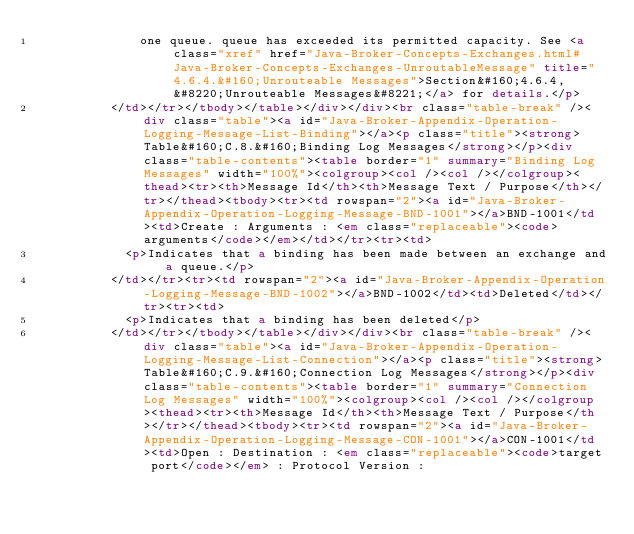<code> <loc_0><loc_0><loc_500><loc_500><_HTML_>              one queue. queue has exceeded its permitted capacity. See <a class="xref" href="Java-Broker-Concepts-Exchanges.html#Java-Broker-Concepts-Exchanges-UnroutableMessage" title="4.6.4.&#160;Unrouteable Messages">Section&#160;4.6.4, &#8220;Unrouteable Messages&#8221;</a> for details.</p>
          </td></tr></tbody></table></div></div><br class="table-break" /><div class="table"><a id="Java-Broker-Appendix-Operation-Logging-Message-List-Binding"></a><p class="title"><strong>Table&#160;C.8.&#160;Binding Log Messages</strong></p><div class="table-contents"><table border="1" summary="Binding Log Messages" width="100%"><colgroup><col /><col /></colgroup><thead><tr><th>Message Id</th><th>Message Text / Purpose</th></tr></thead><tbody><tr><td rowspan="2"><a id="Java-Broker-Appendix-Operation-Logging-Message-BND-1001"></a>BND-1001</td><td>Create : Arguments : <em class="replaceable"><code>arguments</code></em></td></tr><tr><td>
            <p>Indicates that a binding has been made between an exchange and a queue.</p>
          </td></tr><tr><td rowspan="2"><a id="Java-Broker-Appendix-Operation-Logging-Message-BND-1002"></a>BND-1002</td><td>Deleted</td></tr><tr><td>
            <p>Indicates that a binding has been deleted</p>
          </td></tr></tbody></table></div></div><br class="table-break" /><div class="table"><a id="Java-Broker-Appendix-Operation-Logging-Message-List-Connection"></a><p class="title"><strong>Table&#160;C.9.&#160;Connection Log Messages</strong></p><div class="table-contents"><table border="1" summary="Connection Log Messages" width="100%"><colgroup><col /><col /></colgroup><thead><tr><th>Message Id</th><th>Message Text / Purpose</th></tr></thead><tbody><tr><td rowspan="2"><a id="Java-Broker-Appendix-Operation-Logging-Message-CON-1001"></a>CON-1001</td><td>Open : Destination : <em class="replaceable"><code>target port</code></em> : Protocol Version :</code> 